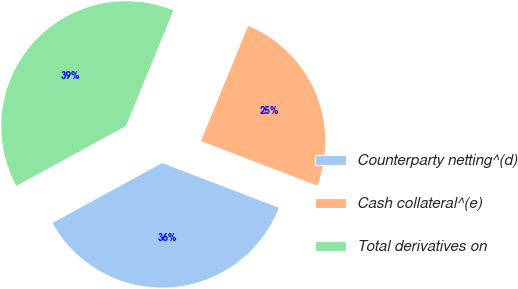Convert chart to OTSL. <chart><loc_0><loc_0><loc_500><loc_500><pie_chart><fcel>Counterparty netting^(d)<fcel>Cash collateral^(e)<fcel>Total derivatives on<nl><fcel>36.22%<fcel>24.62%<fcel>39.16%<nl></chart> 